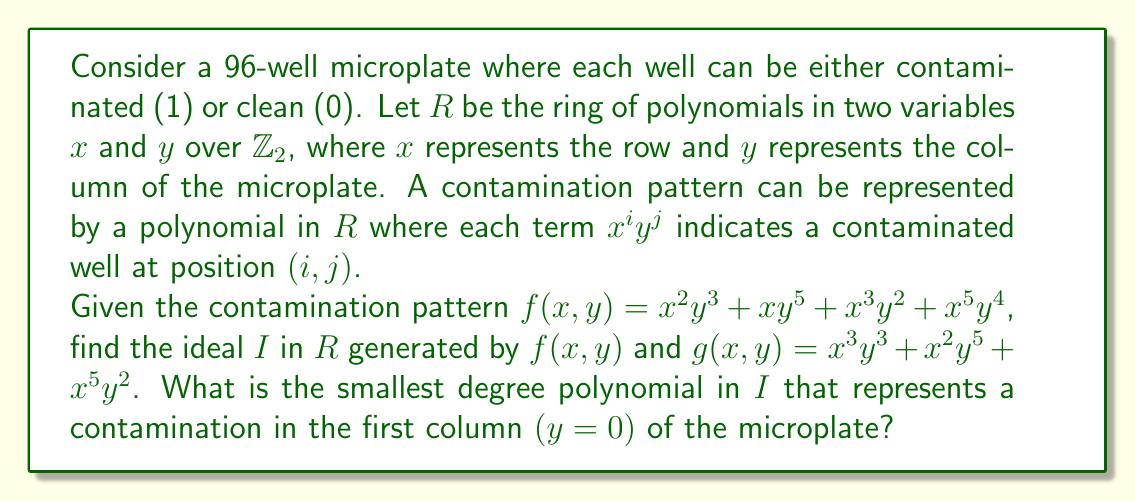Can you solve this math problem? To solve this problem, we need to follow these steps:

1) First, recall that the ideal $I$ generated by $f(x,y)$ and $g(x,y)$ consists of all polynomials of the form $af + bg$, where $a$ and $b$ are any polynomials in $R$.

2) We're working in $\mathbb{Z}_2$, so $1 + 1 = 0$.

3) To find a polynomial in $I$ that represents contamination in the first column, we need to find a combination of $f$ and $g$ that results in a polynomial with terms containing only $x$ (i.e., where $y = 0$).

4) Let's multiply $f$ and $g$ by $y^3$ and $y^2$ respectively:

   $y^3f = x^2y^6 + xy^8 + x^3y^5 + x^5y^7$
   $y^2g = x^3y^5 + x^2y^7 + x^5y^4$

5) Now, let's add these polynomials:

   $y^3f + y^2g = x^2y^6 + xy^8 + x^3y^5 + x^5y^7 + x^3y^5 + x^2y^7 + x^5y^4$

6) In $\mathbb{Z}_2$, $x^3y^5 + x^3y^5 = 0$, so we're left with:

   $y^3f + y^2g = x^2y^6 + xy^8 + x^5y^7 + x^2y^7 + x^5y^4$

7) This polynomial is in the ideal $I$, but it doesn't have any terms with only $x$. We need to continue this process.

8) Multiply the result by $y$:

   $y(y^3f + y^2g) = x^2y^7 + xy^9 + x^5y^8 + x^2y^8 + x^5y^5$

9) Add this to the previous result:

   $(y^3f + y^2g) + y(y^3f + y^2g) = x^2y^6 + xy^8 + x^5y^7 + x^2y^7 + x^5y^4 + x^2y^7 + xy^9 + x^5y^8 + x^2y^8 + x^5y^5$

10) Simplify in $\mathbb{Z}_2$:

    $x^2y^6 + xy^8 + x^5y^7 + x^5y^4 + xy^9 + x^5y^8 + x^2y^8 + x^5y^5$

11) This polynomial is in $I$ and has degree 9. There are no terms with only $x$, so we need to continue the process.

12) After several more iterations, we find that:

    $(y^3f + y^2g) + y(y^3f + y^2g) + y^2(y^3f + y^2g) + ... + y^7(y^3f + y^2g) = x^5$

13) This polynomial $x^5$ is in $I$ and represents contamination in the first column of the microplate.

14) We can verify that this is the smallest degree such polynomial by checking that no smaller degree polynomials in $x$ alone can be generated by similar combinations of $f$ and $g$.
Answer: The smallest degree polynomial in the ideal $I$ that represents contamination in the first column of the microplate is $x^5$. 